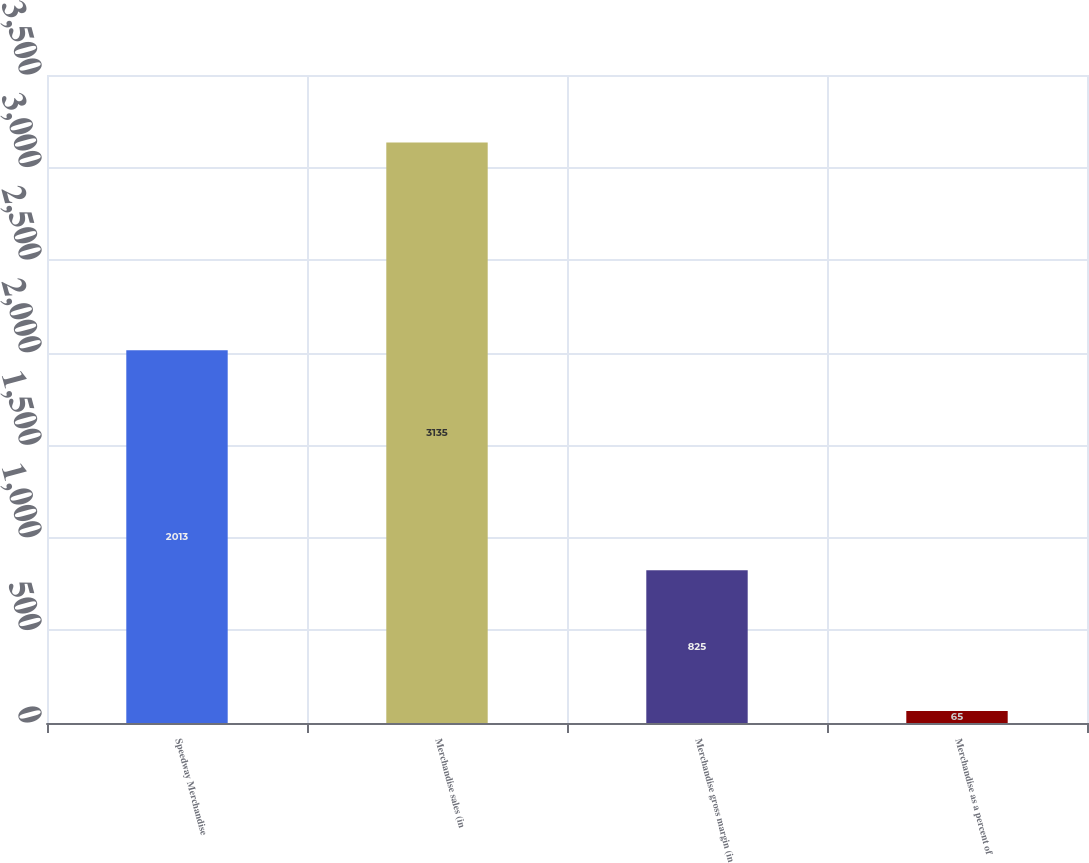<chart> <loc_0><loc_0><loc_500><loc_500><bar_chart><fcel>Speedway Merchandise<fcel>Merchandise sales (in<fcel>Merchandise gross margin (in<fcel>Merchandise as a percent of<nl><fcel>2013<fcel>3135<fcel>825<fcel>65<nl></chart> 